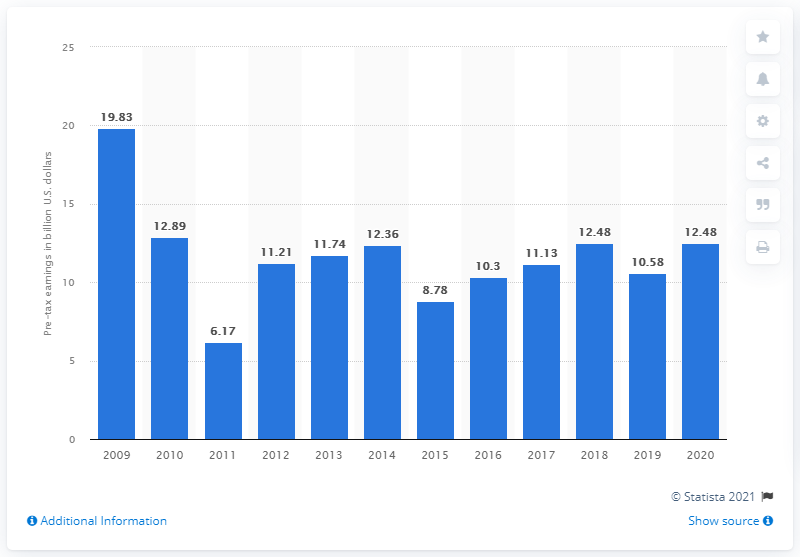Outline some significant characteristics in this image. The pre-tax earnings of Goldman Sachs in dollars in 2020 were $12.48. 